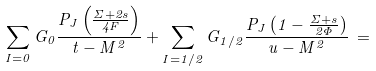Convert formula to latex. <formula><loc_0><loc_0><loc_500><loc_500>\sum _ { I = 0 } G _ { 0 } \frac { P _ { J } \left ( \frac { \Sigma + 2 s } { 4 F } \right ) } { t - M ^ { 2 } } + \sum _ { I = 1 / 2 } G _ { 1 / 2 } \frac { P _ { J } \left ( 1 - \frac { \Sigma + s } { 2 \Phi } \right ) } { u - M ^ { 2 } } \, =</formula> 